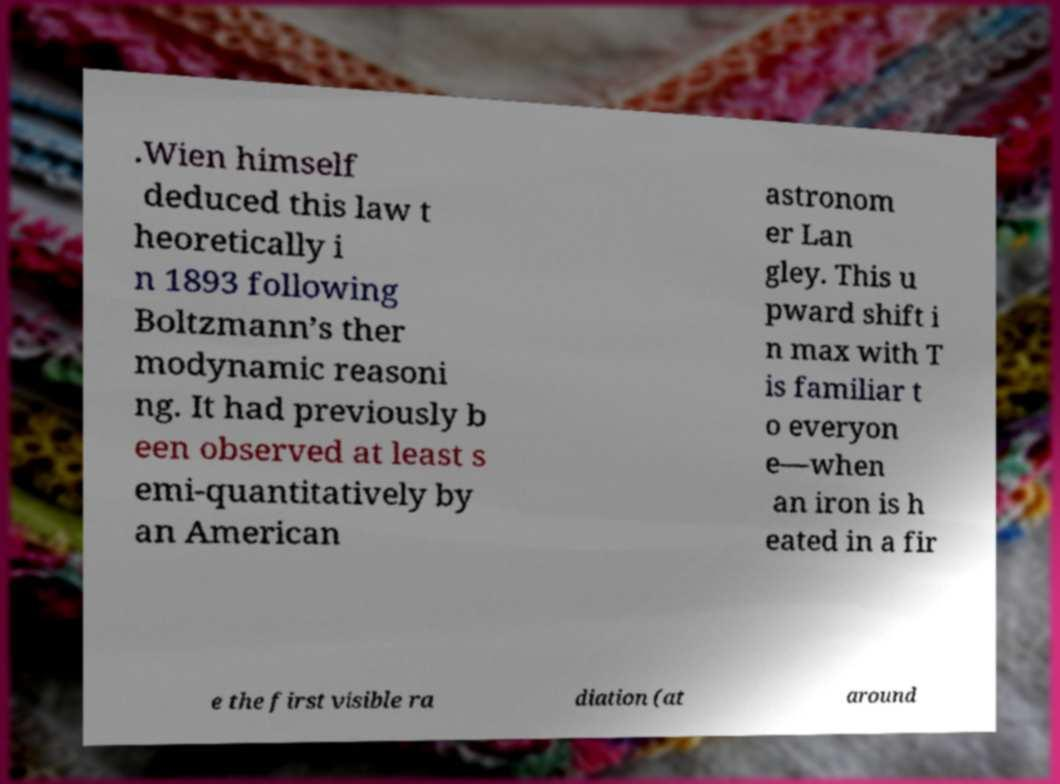Please read and relay the text visible in this image. What does it say? .Wien himself deduced this law t heoretically i n 1893 following Boltzmann’s ther modynamic reasoni ng. It had previously b een observed at least s emi-quantitatively by an American astronom er Lan gley. This u pward shift i n max with T is familiar t o everyon e—when an iron is h eated in a fir e the first visible ra diation (at around 